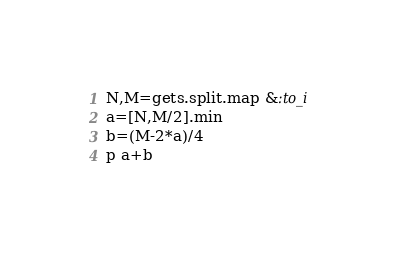<code> <loc_0><loc_0><loc_500><loc_500><_Ruby_>N,M=gets.split.map &:to_i
a=[N,M/2].min
b=(M-2*a)/4
p a+b</code> 